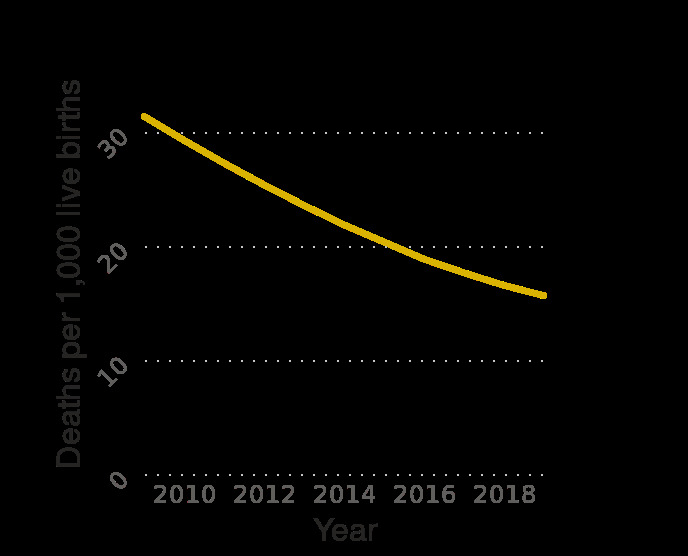<image>
What factors may have contributed to the decrease in infant mortality rate in Uzbekistan? The description does not provide information about the factors that contributed to the decrease in infant mortality rate in Uzbekistan. What is being measured along the y-axis in the line diagram?  The number of deaths per 1,000 live births. please enumerates aspects of the construction of the chart Uzbekistan : Infant mortality rate from 2009 to 2019 (in deaths per 1,000 live births) is a line diagram. Along the x-axis, Year is defined. Deaths per 1,000 live births is measured along a linear scale with a minimum of 0 and a maximum of 30 on the y-axis. 